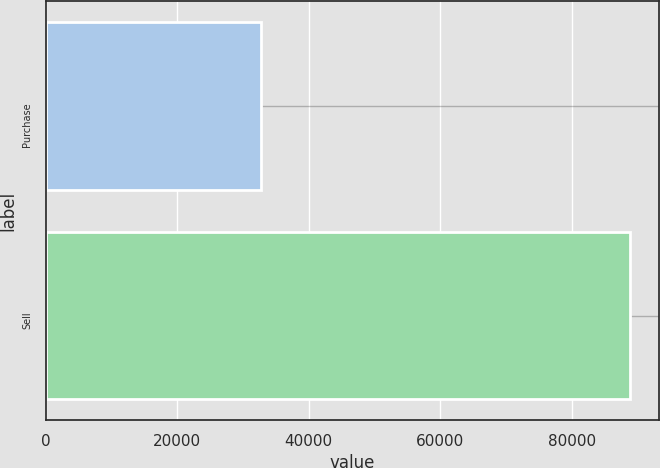Convert chart to OTSL. <chart><loc_0><loc_0><loc_500><loc_500><bar_chart><fcel>Purchase<fcel>Sell<nl><fcel>32775<fcel>88800<nl></chart> 